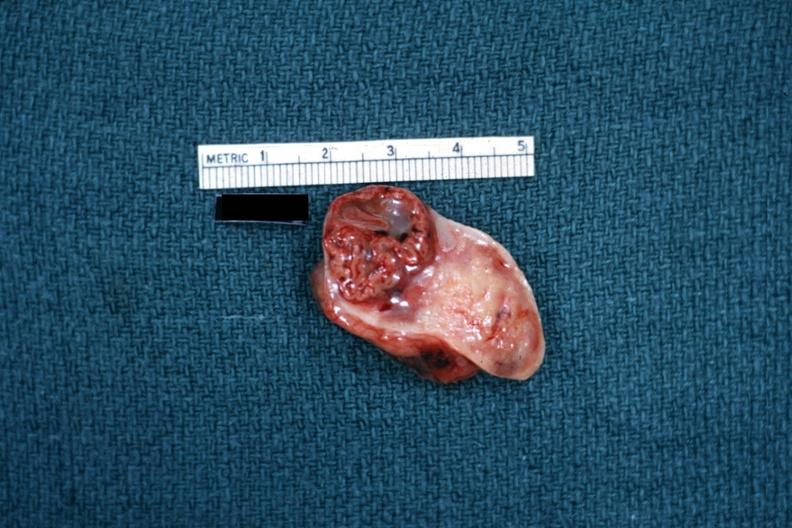s this typical lesion present?
Answer the question using a single word or phrase. No 